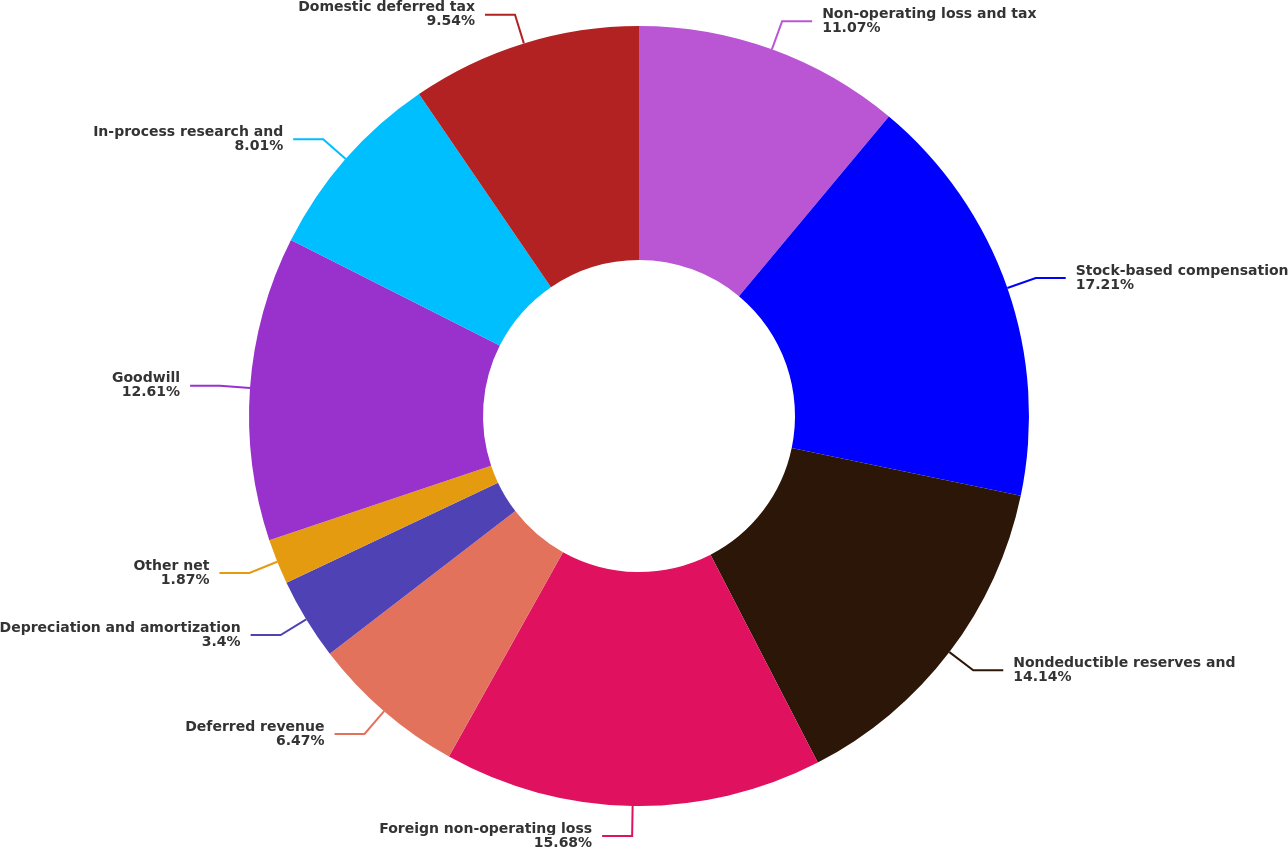Convert chart. <chart><loc_0><loc_0><loc_500><loc_500><pie_chart><fcel>Non-operating loss and tax<fcel>Stock-based compensation<fcel>Nondeductible reserves and<fcel>Foreign non-operating loss<fcel>Deferred revenue<fcel>Depreciation and amortization<fcel>Other net<fcel>Goodwill<fcel>In-process research and<fcel>Domestic deferred tax<nl><fcel>11.07%<fcel>17.21%<fcel>14.14%<fcel>15.68%<fcel>6.47%<fcel>3.4%<fcel>1.87%<fcel>12.61%<fcel>8.01%<fcel>9.54%<nl></chart> 